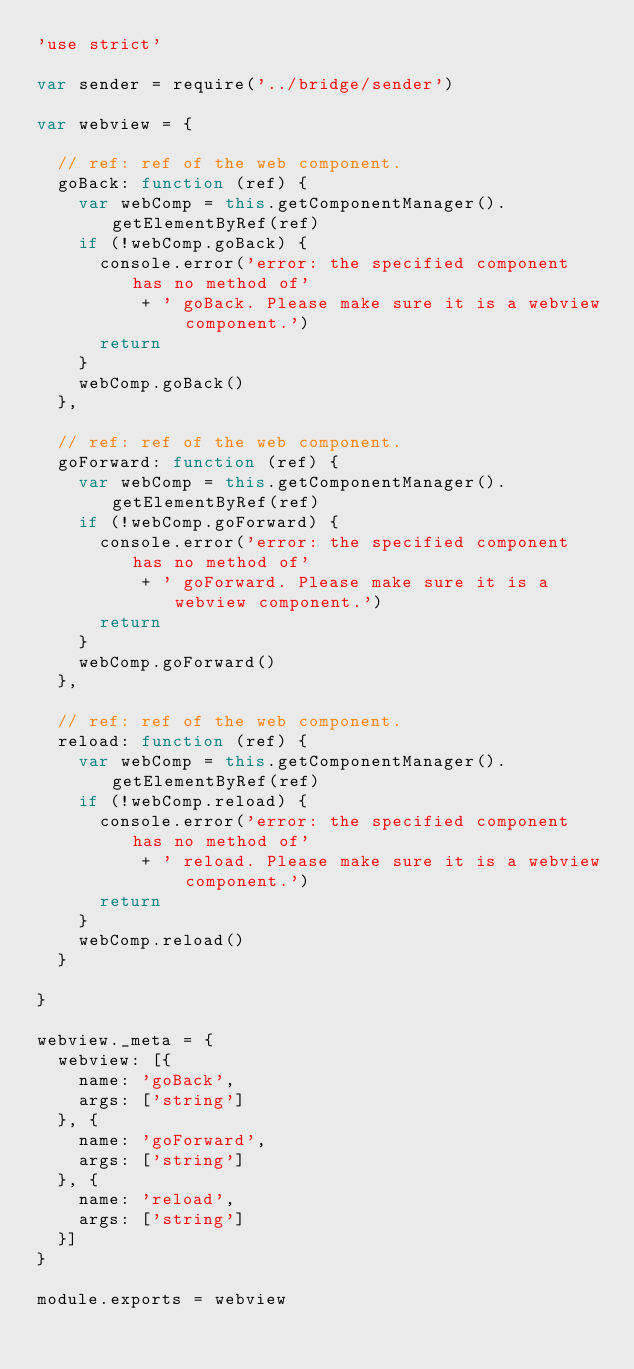<code> <loc_0><loc_0><loc_500><loc_500><_JavaScript_>'use strict'

var sender = require('../bridge/sender')

var webview = {

  // ref: ref of the web component.
  goBack: function (ref) {
    var webComp = this.getComponentManager().getElementByRef(ref)
    if (!webComp.goBack) {
      console.error('error: the specified component has no method of'
          + ' goBack. Please make sure it is a webview component.')
      return
    }
    webComp.goBack()
  },

  // ref: ref of the web component.
  goForward: function (ref) {
    var webComp = this.getComponentManager().getElementByRef(ref)
    if (!webComp.goForward) {
      console.error('error: the specified component has no method of'
          + ' goForward. Please make sure it is a webview component.')
      return
    }
    webComp.goForward()
  },

  // ref: ref of the web component.
  reload: function (ref) {
    var webComp = this.getComponentManager().getElementByRef(ref)
    if (!webComp.reload) {
      console.error('error: the specified component has no method of'
          + ' reload. Please make sure it is a webview component.')
      return
    }
    webComp.reload()
  }

}

webview._meta = {
  webview: [{
    name: 'goBack',
    args: ['string']
  }, {
    name: 'goForward',
    args: ['string']
  }, {
    name: 'reload',
    args: ['string']
  }]
}

module.exports = webview
</code> 